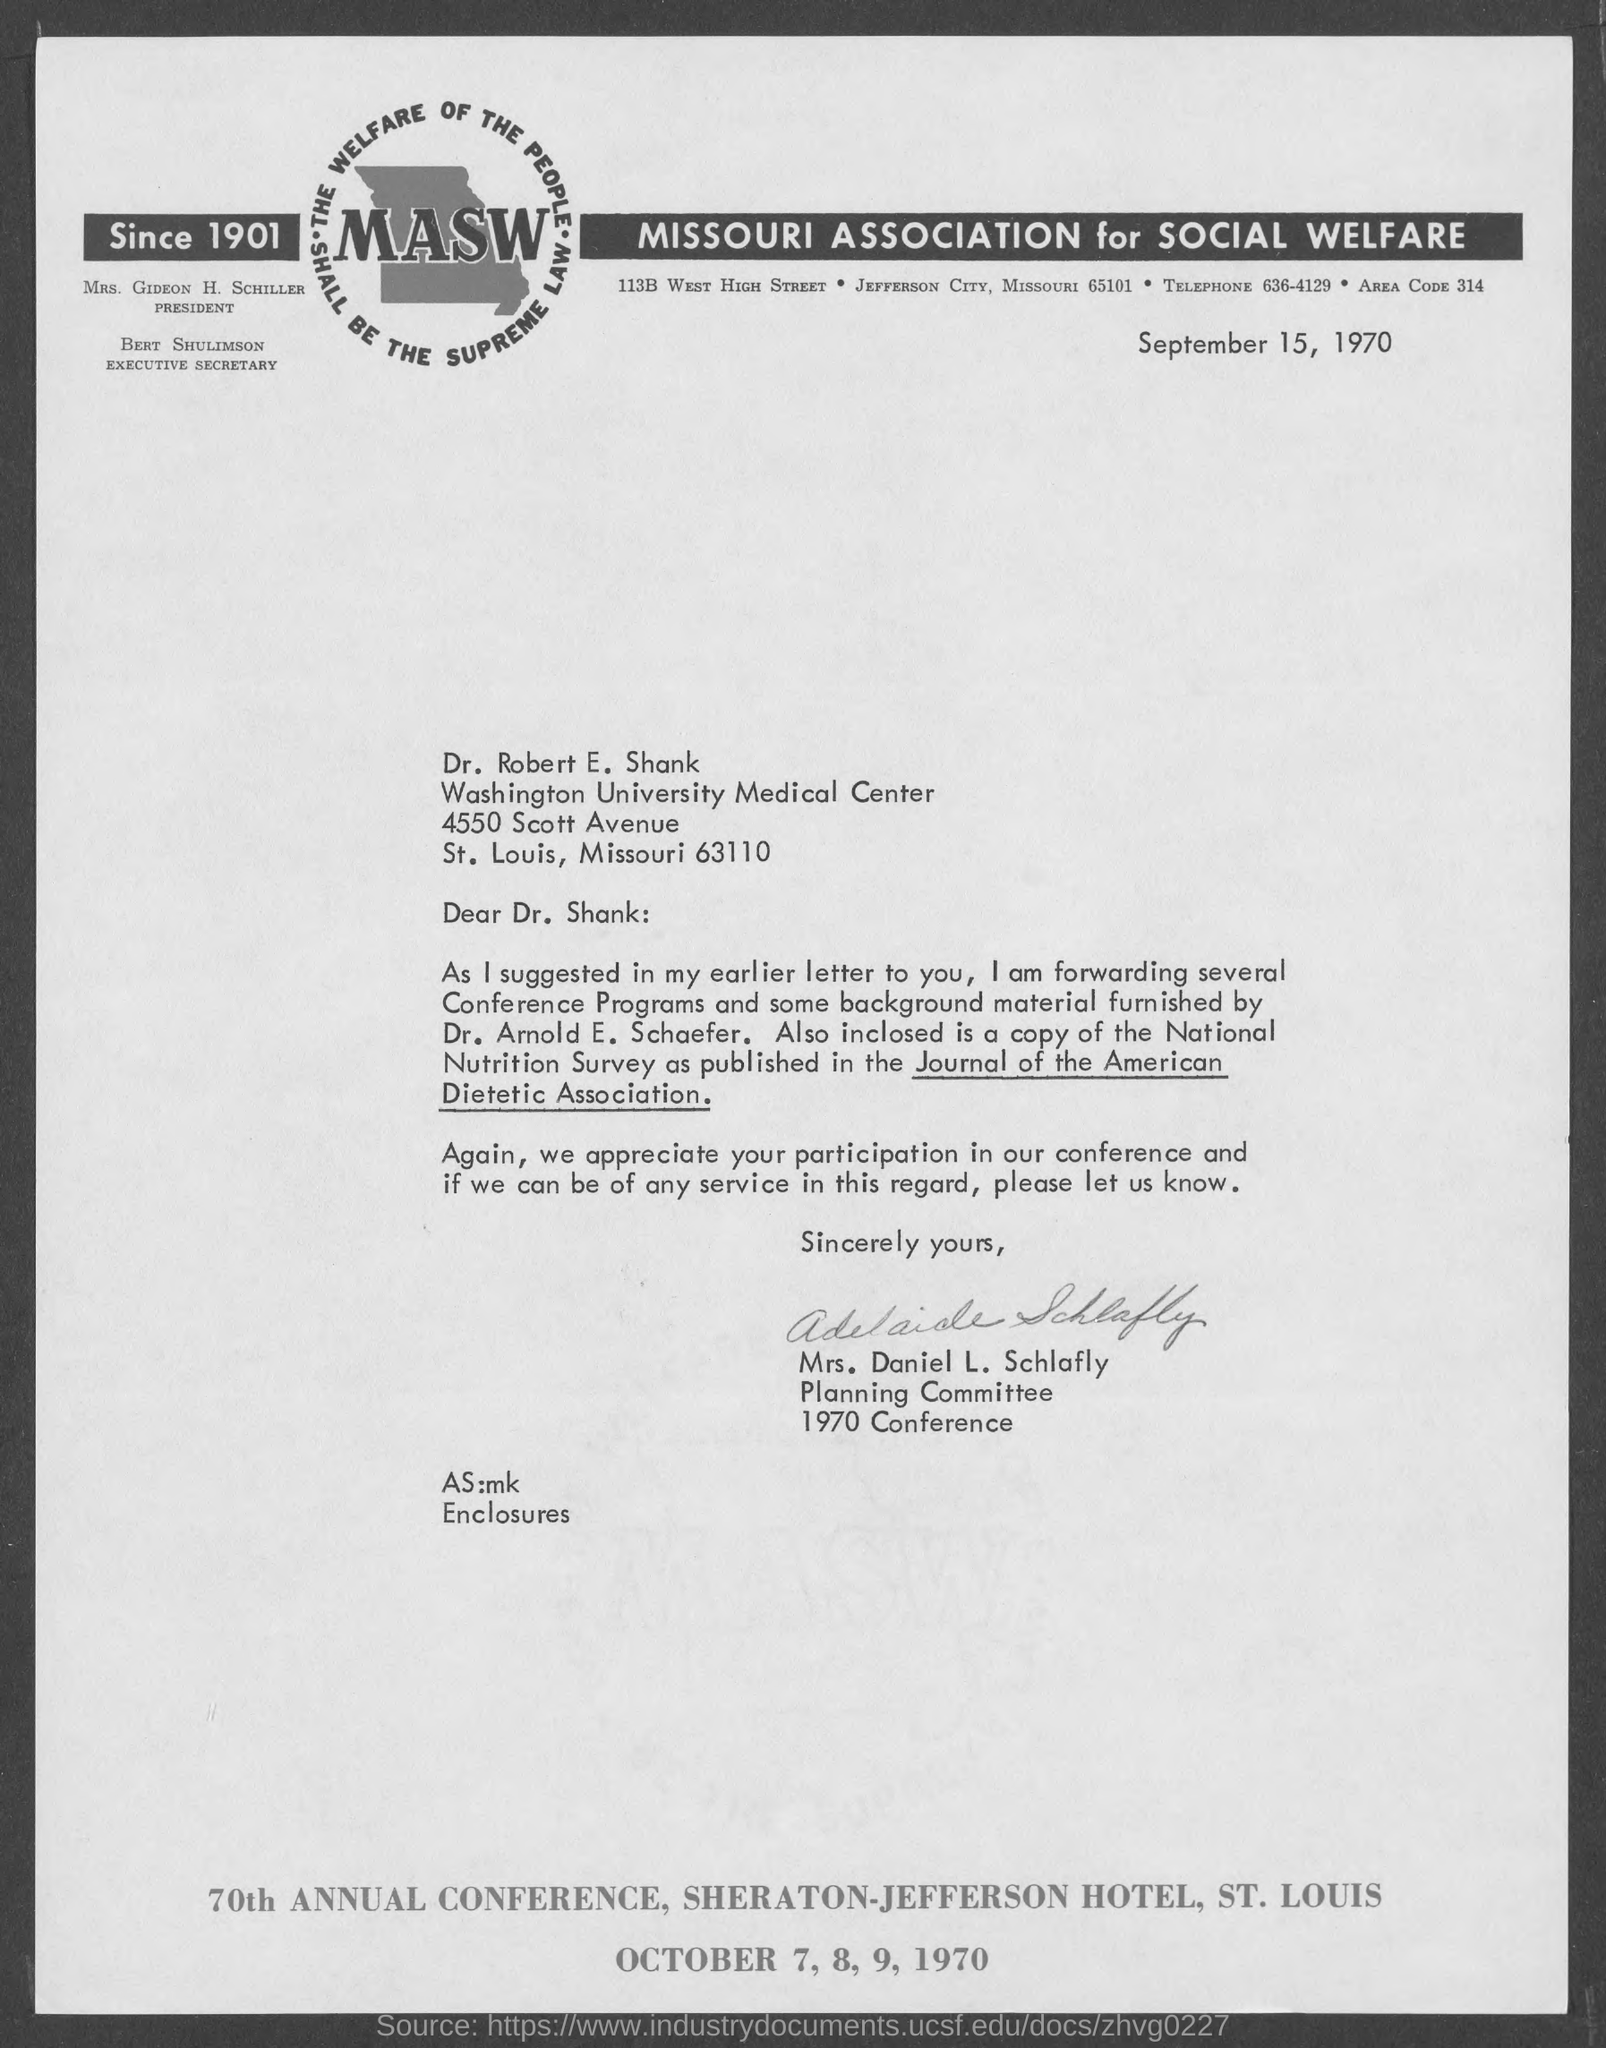To whom is this letter addressed to?
Keep it short and to the point. Dr. Robert E. Shank. Who is this letter from?
Give a very brief answer. Mrs. Daniel L. Schlafly. 